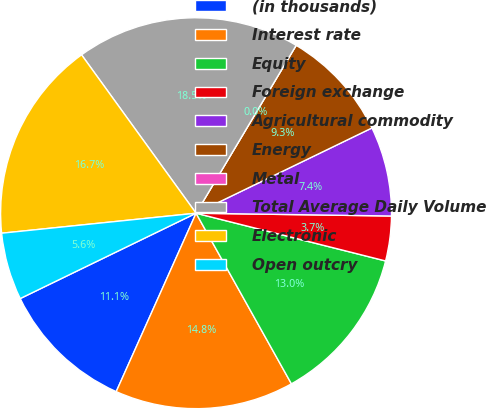<chart> <loc_0><loc_0><loc_500><loc_500><pie_chart><fcel>(in thousands)<fcel>Interest rate<fcel>Equity<fcel>Foreign exchange<fcel>Agricultural commodity<fcel>Energy<fcel>Metal<fcel>Total Average Daily Volume<fcel>Electronic<fcel>Open outcry<nl><fcel>11.11%<fcel>14.81%<fcel>12.96%<fcel>3.7%<fcel>7.41%<fcel>9.26%<fcel>0.0%<fcel>18.52%<fcel>16.67%<fcel>5.56%<nl></chart> 